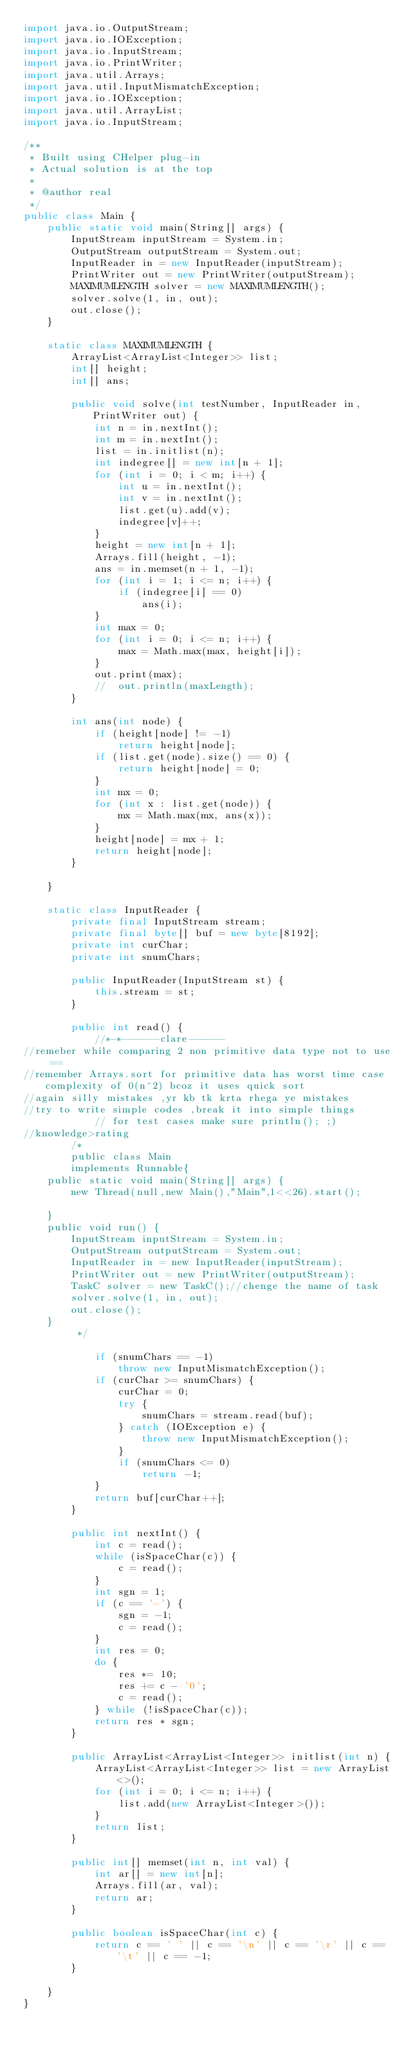<code> <loc_0><loc_0><loc_500><loc_500><_Java_>import java.io.OutputStream;
import java.io.IOException;
import java.io.InputStream;
import java.io.PrintWriter;
import java.util.Arrays;
import java.util.InputMismatchException;
import java.io.IOException;
import java.util.ArrayList;
import java.io.InputStream;

/**
 * Built using CHelper plug-in
 * Actual solution is at the top
 *
 * @author real
 */
public class Main {
    public static void main(String[] args) {
        InputStream inputStream = System.in;
        OutputStream outputStream = System.out;
        InputReader in = new InputReader(inputStream);
        PrintWriter out = new PrintWriter(outputStream);
        MAXIMUMLENGTH solver = new MAXIMUMLENGTH();
        solver.solve(1, in, out);
        out.close();
    }

    static class MAXIMUMLENGTH {
        ArrayList<ArrayList<Integer>> list;
        int[] height;
        int[] ans;

        public void solve(int testNumber, InputReader in, PrintWriter out) {
            int n = in.nextInt();
            int m = in.nextInt();
            list = in.initlist(n);
            int indegree[] = new int[n + 1];
            for (int i = 0; i < m; i++) {
                int u = in.nextInt();
                int v = in.nextInt();
                list.get(u).add(v);
                indegree[v]++;
            }
            height = new int[n + 1];
            Arrays.fill(height, -1);
            ans = in.memset(n + 1, -1);
            for (int i = 1; i <= n; i++) {
                if (indegree[i] == 0)
                    ans(i);
            }
            int max = 0;
            for (int i = 0; i <= n; i++) {
                max = Math.max(max, height[i]);
            }
            out.print(max);
            //  out.println(maxLength);
        }

        int ans(int node) {
            if (height[node] != -1)
                return height[node];
            if (list.get(node).size() == 0) {
                return height[node] = 0;
            }
            int mx = 0;
            for (int x : list.get(node)) {
                mx = Math.max(mx, ans(x));
            }
            height[node] = mx + 1;
            return height[node];
        }

    }

    static class InputReader {
        private final InputStream stream;
        private final byte[] buf = new byte[8192];
        private int curChar;
        private int snumChars;

        public InputReader(InputStream st) {
            this.stream = st;
        }

        public int read() {
            //*-*------clare------
//remeber while comparing 2 non primitive data type not to use ==
//remember Arrays.sort for primitive data has worst time case complexity of 0(n^2) bcoz it uses quick sort
//again silly mistakes ,yr kb tk krta rhega ye mistakes
//try to write simple codes ,break it into simple things
            // for test cases make sure println(); ;)
//knowledge>rating
        /*
        public class Main
        implements Runnable{
    public static void main(String[] args) {
        new Thread(null,new Main(),"Main",1<<26).start();

    }
    public void run() {
        InputStream inputStream = System.in;
        OutputStream outputStream = System.out;
        InputReader in = new InputReader(inputStream);
        PrintWriter out = new PrintWriter(outputStream);
        TaskC solver = new TaskC();//chenge the name of task
        solver.solve(1, in, out);
        out.close();
    }
         */

            if (snumChars == -1)
                throw new InputMismatchException();
            if (curChar >= snumChars) {
                curChar = 0;
                try {
                    snumChars = stream.read(buf);
                } catch (IOException e) {
                    throw new InputMismatchException();
                }
                if (snumChars <= 0)
                    return -1;
            }
            return buf[curChar++];
        }

        public int nextInt() {
            int c = read();
            while (isSpaceChar(c)) {
                c = read();
            }
            int sgn = 1;
            if (c == '-') {
                sgn = -1;
                c = read();
            }
            int res = 0;
            do {
                res *= 10;
                res += c - '0';
                c = read();
            } while (!isSpaceChar(c));
            return res * sgn;
        }

        public ArrayList<ArrayList<Integer>> initlist(int n) {
            ArrayList<ArrayList<Integer>> list = new ArrayList<>();
            for (int i = 0; i <= n; i++) {
                list.add(new ArrayList<Integer>());
            }
            return list;
        }

        public int[] memset(int n, int val) {
            int ar[] = new int[n];
            Arrays.fill(ar, val);
            return ar;
        }

        public boolean isSpaceChar(int c) {
            return c == ' ' || c == '\n' || c == '\r' || c == '\t' || c == -1;
        }

    }
}

</code> 